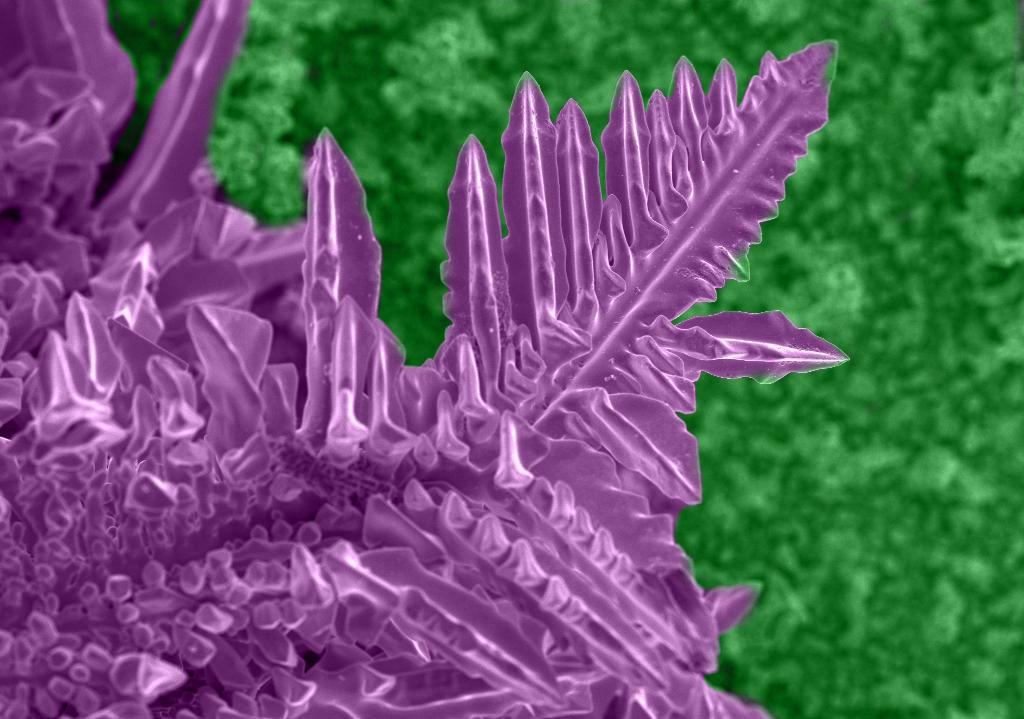What type of living organisms can be seen in the image? Plants can be seen in the image. What color are some of the plants in the image? Some plants are green in color, while others are purple in color. What type of humor can be found in the image? There is no humor present in the image, as it features plants of different colors. Can you tell me how many frogs are visible in the image? There are no frogs present in the image; it features plants of different colors. 